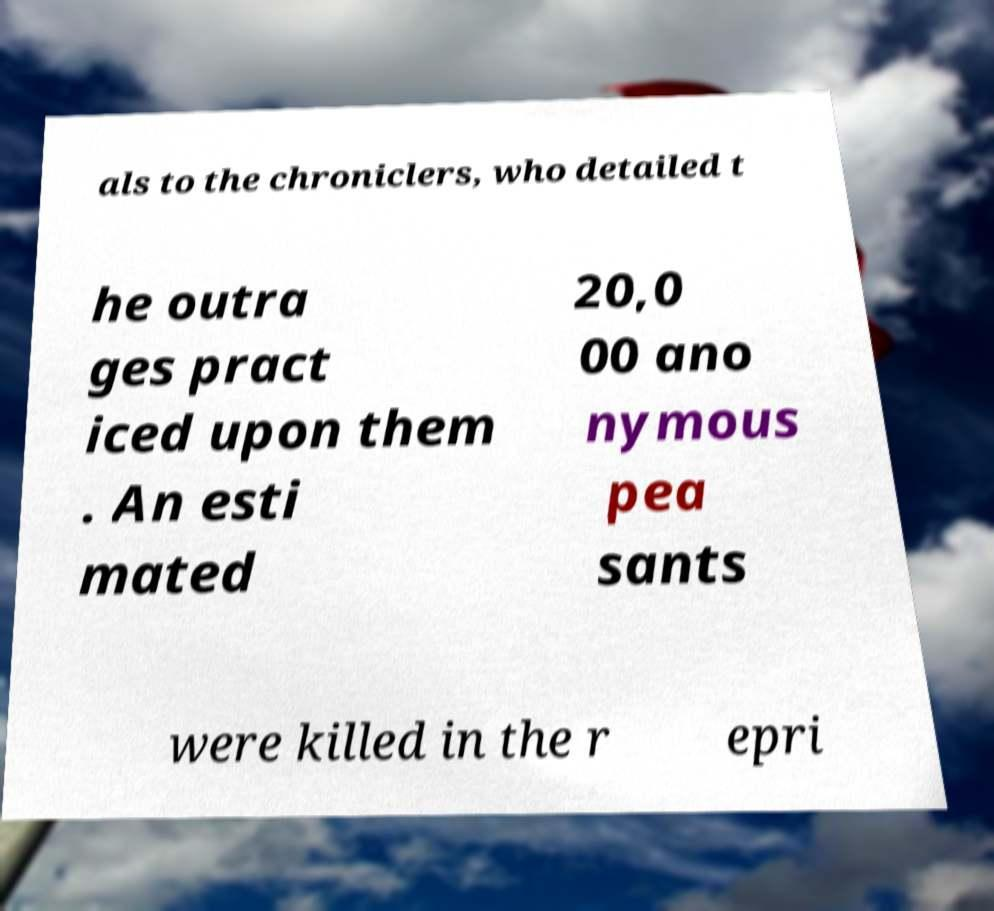Can you read and provide the text displayed in the image?This photo seems to have some interesting text. Can you extract and type it out for me? als to the chroniclers, who detailed t he outra ges pract iced upon them . An esti mated 20,0 00 ano nymous pea sants were killed in the r epri 